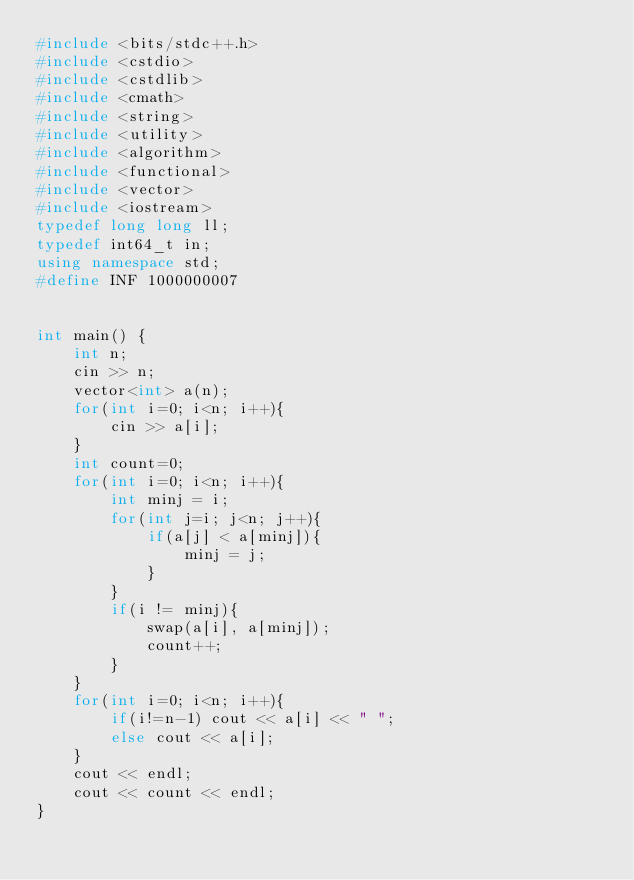Convert code to text. <code><loc_0><loc_0><loc_500><loc_500><_C++_>#include <bits/stdc++.h>
#include <cstdio>
#include <cstdlib>
#include <cmath>
#include <string>
#include <utility>
#include <algorithm>
#include <functional>
#include <vector>
#include <iostream>
typedef long long ll;
typedef int64_t in;
using namespace std;
#define INF 1000000007


int main() {
	int n;
    cin >> n;
    vector<int> a(n);
    for(int i=0; i<n; i++){
        cin >> a[i];
    }
    int count=0;
    for(int i=0; i<n; i++){
        int minj = i;
        for(int j=i; j<n; j++){
            if(a[j] < a[minj]){
                minj = j;
            }
        }
        if(i != minj){
            swap(a[i], a[minj]);
            count++;
        }
    }
    for(int i=0; i<n; i++){
        if(i!=n-1) cout << a[i] << " ";
        else cout << a[i];
    }
    cout << endl;
    cout << count << endl;
}
</code> 